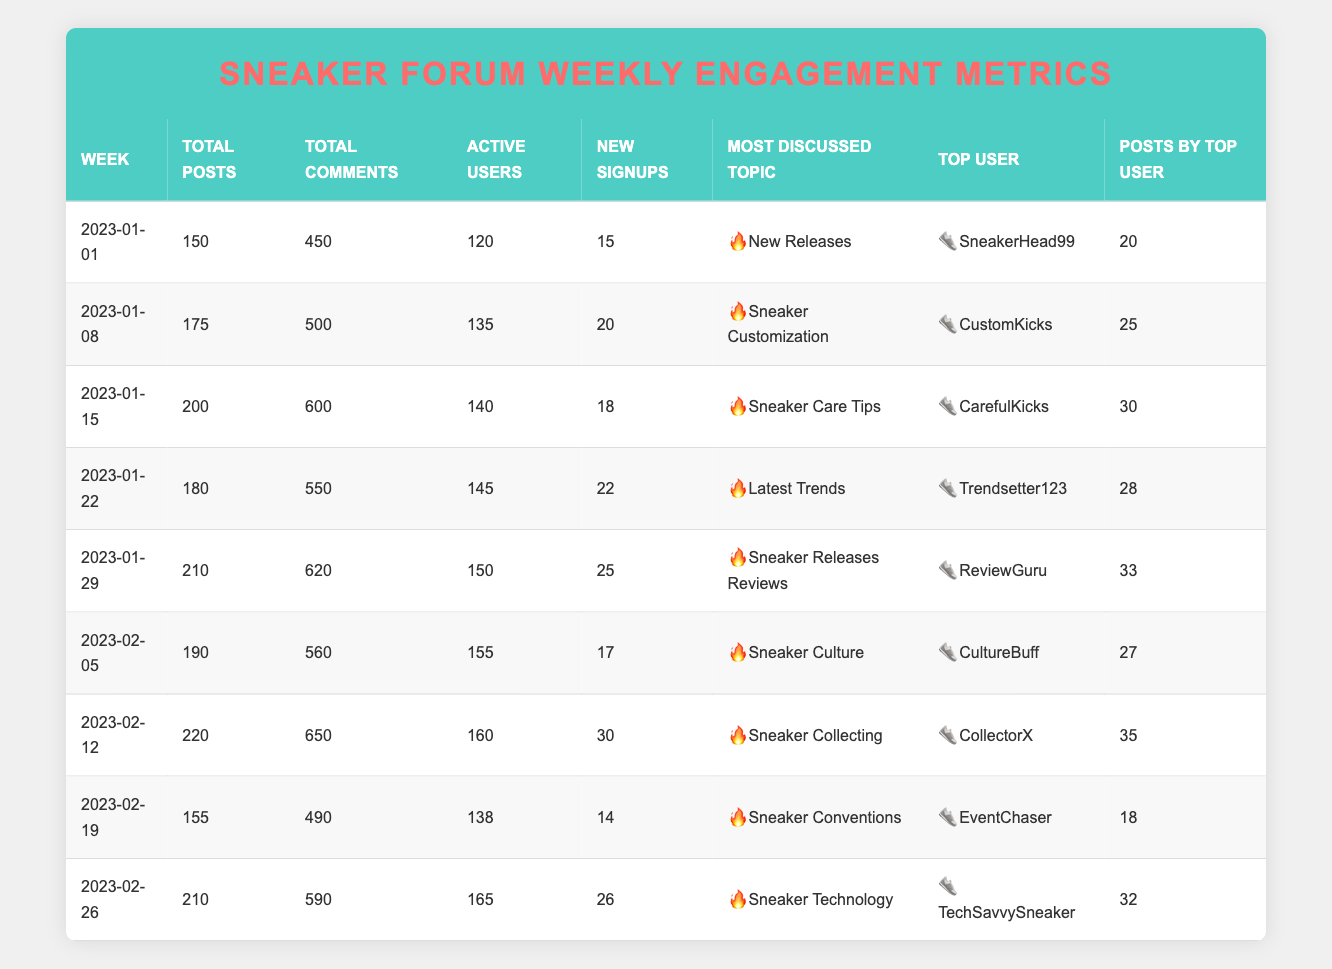What was the total number of posts for the week of 2023-01-15? The table lists a row for the week of 2023-01-15, where the "Total Posts" column shows a value of 200.
Answer: 200 Which week had the highest number of new signups? By scanning through the "New Signups" column, the maximum value is 30, which corresponds to the week of 2023-02-12.
Answer: 2023-02-12 How many more total comments were made in the week of 2023-01-29 compared to the week of 2023-02-19? The total comments for 2023-01-29 is 620 and for 2023-02-19 is 490. The difference is 620 - 490 = 130.
Answer: 130 True or False: The most discussed topic in the week of 2023-02-05 was "Sneaker Culture." The table indicates that the most discussed topic for the week of 2023-02-05 is indeed "Sneaker Culture," confirming the statement as true.
Answer: True What is the average number of total posts from the weeks listed in January? The weeks in January are: 150 (2023-01-01), 175 (2023-01-08), 200 (2023-01-15), 180 (2023-01-22), and 210 (2023-01-29). Summing these gives 150 + 175 + 200 + 180 + 210 = 915, and dividing by 5 yields an average of 915 / 5 = 183.
Answer: 183 In which week did "ReviewGuru" post the most? The table shows "ReviewGuru" as the top user for the week of 2023-01-29 with 33 posts, which is more than any other week listed.
Answer: 2023-01-29 How many active users were there in total across all weeks listed? The active users per week are 120, 135, 140, 145, 150, 155, 160, 138, and 165. Summing these yields 120 + 135 + 140 + 145 + 150 + 155 + 160 + 138 + 165 = 1308.
Answer: 1308 Which topic was discussed the least in terms of total comments? By reviewing the "Total Comments" column, the least value is found for the week of 2023-02-19 with 490 comments, which corresponds to the topic of "Sneaker Conventions."
Answer: Sneaker Conventions What is the difference in total posts between the week with the highest posts and the week with the lowest? The maximum posts are 220 (week of 2023-02-12) and the minimum are 150 (week of 2023-01-01). The difference is calculated as 220 - 150 = 70.
Answer: 70 